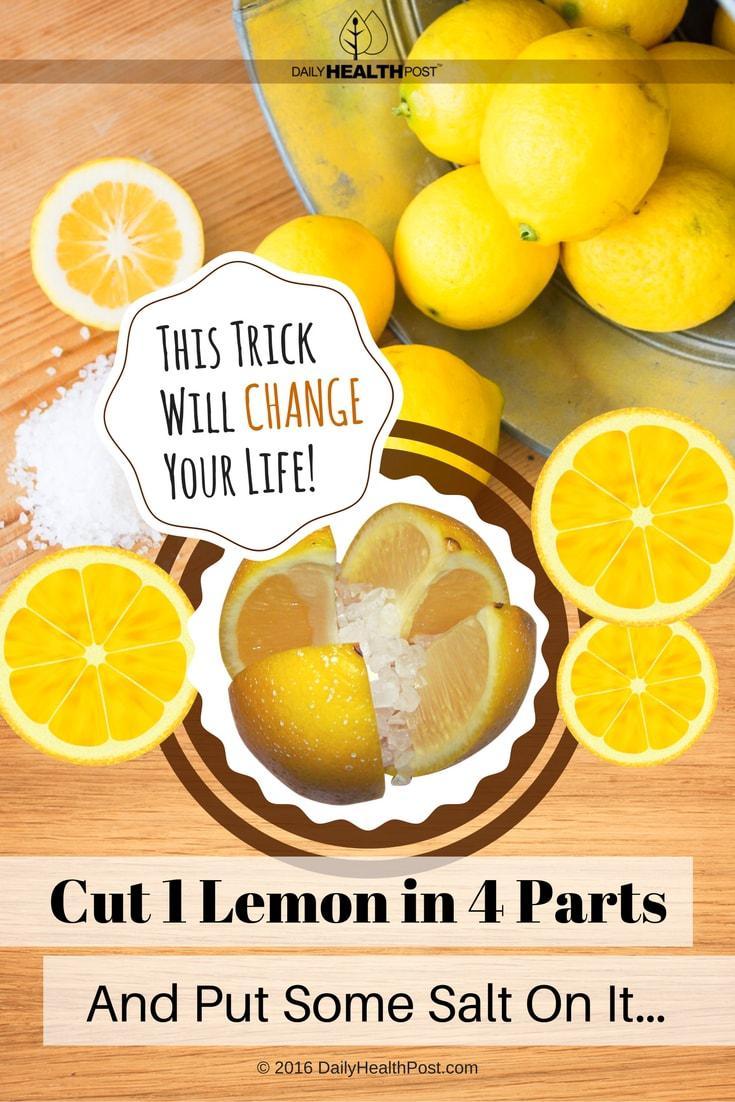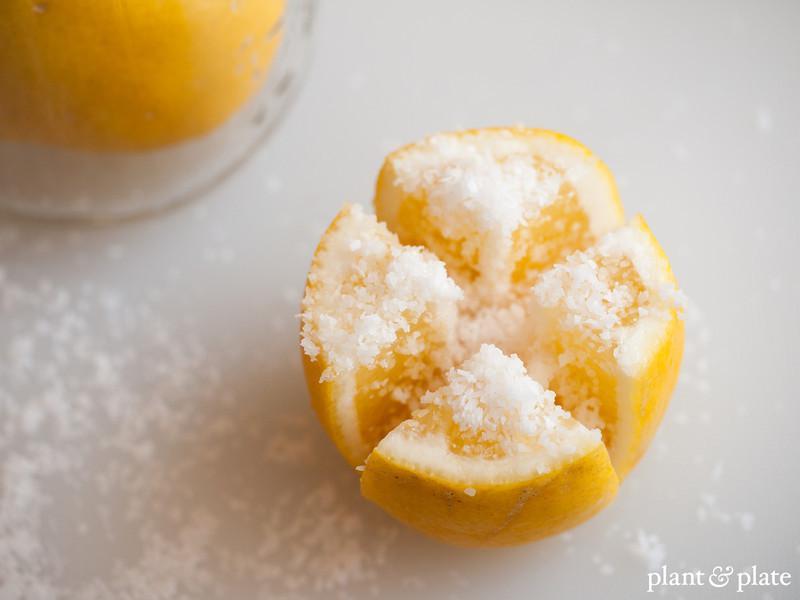The first image is the image on the left, the second image is the image on the right. Assess this claim about the two images: "The right image shows a lemon cross cut into four parts with salt poured on it.". Correct or not? Answer yes or no. Yes. 